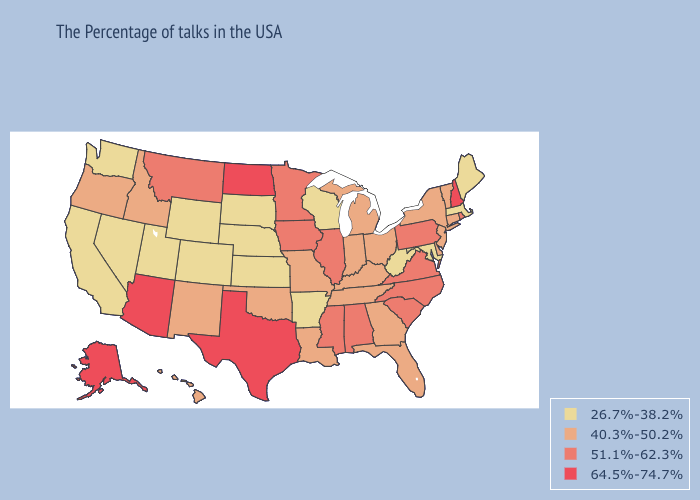Name the states that have a value in the range 40.3%-50.2%?
Answer briefly. Vermont, Connecticut, New York, New Jersey, Delaware, Ohio, Florida, Georgia, Michigan, Kentucky, Indiana, Tennessee, Louisiana, Missouri, Oklahoma, New Mexico, Idaho, Oregon, Hawaii. Does Washington have a lower value than Utah?
Give a very brief answer. No. Name the states that have a value in the range 51.1%-62.3%?
Write a very short answer. Rhode Island, Pennsylvania, Virginia, North Carolina, South Carolina, Alabama, Illinois, Mississippi, Minnesota, Iowa, Montana. Name the states that have a value in the range 51.1%-62.3%?
Write a very short answer. Rhode Island, Pennsylvania, Virginia, North Carolina, South Carolina, Alabama, Illinois, Mississippi, Minnesota, Iowa, Montana. Which states have the lowest value in the West?
Write a very short answer. Wyoming, Colorado, Utah, Nevada, California, Washington. Does Maryland have the lowest value in the South?
Quick response, please. Yes. Does the map have missing data?
Keep it brief. No. Name the states that have a value in the range 26.7%-38.2%?
Give a very brief answer. Maine, Massachusetts, Maryland, West Virginia, Wisconsin, Arkansas, Kansas, Nebraska, South Dakota, Wyoming, Colorado, Utah, Nevada, California, Washington. Name the states that have a value in the range 64.5%-74.7%?
Concise answer only. New Hampshire, Texas, North Dakota, Arizona, Alaska. What is the lowest value in the West?
Write a very short answer. 26.7%-38.2%. What is the highest value in states that border Michigan?
Keep it brief. 40.3%-50.2%. Among the states that border Missouri , does Kentucky have the lowest value?
Short answer required. No. Which states have the highest value in the USA?
Keep it brief. New Hampshire, Texas, North Dakota, Arizona, Alaska. How many symbols are there in the legend?
Give a very brief answer. 4. Name the states that have a value in the range 64.5%-74.7%?
Quick response, please. New Hampshire, Texas, North Dakota, Arizona, Alaska. 